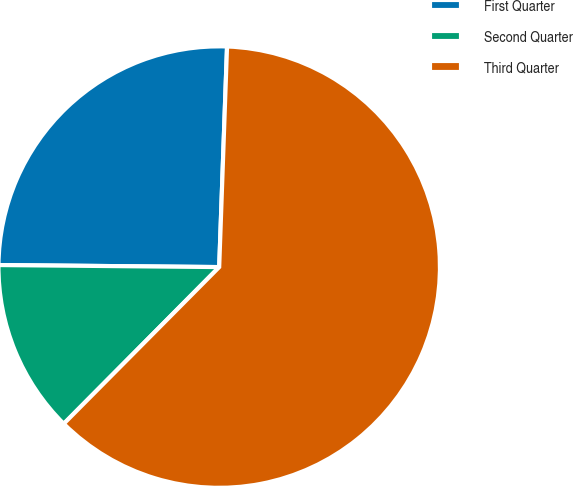<chart> <loc_0><loc_0><loc_500><loc_500><pie_chart><fcel>First Quarter<fcel>Second Quarter<fcel>Third Quarter<nl><fcel>25.42%<fcel>12.71%<fcel>61.87%<nl></chart> 